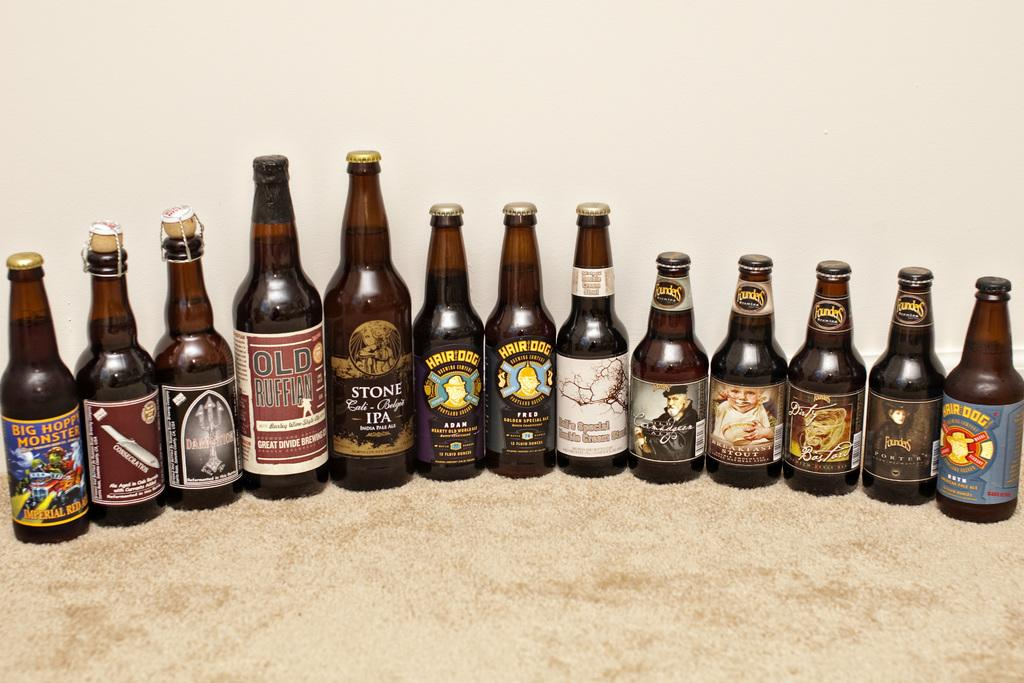Provide a one-sentence caption for the provided image. A bottle on the far left has a label that says, Big Hoppy Monster. 